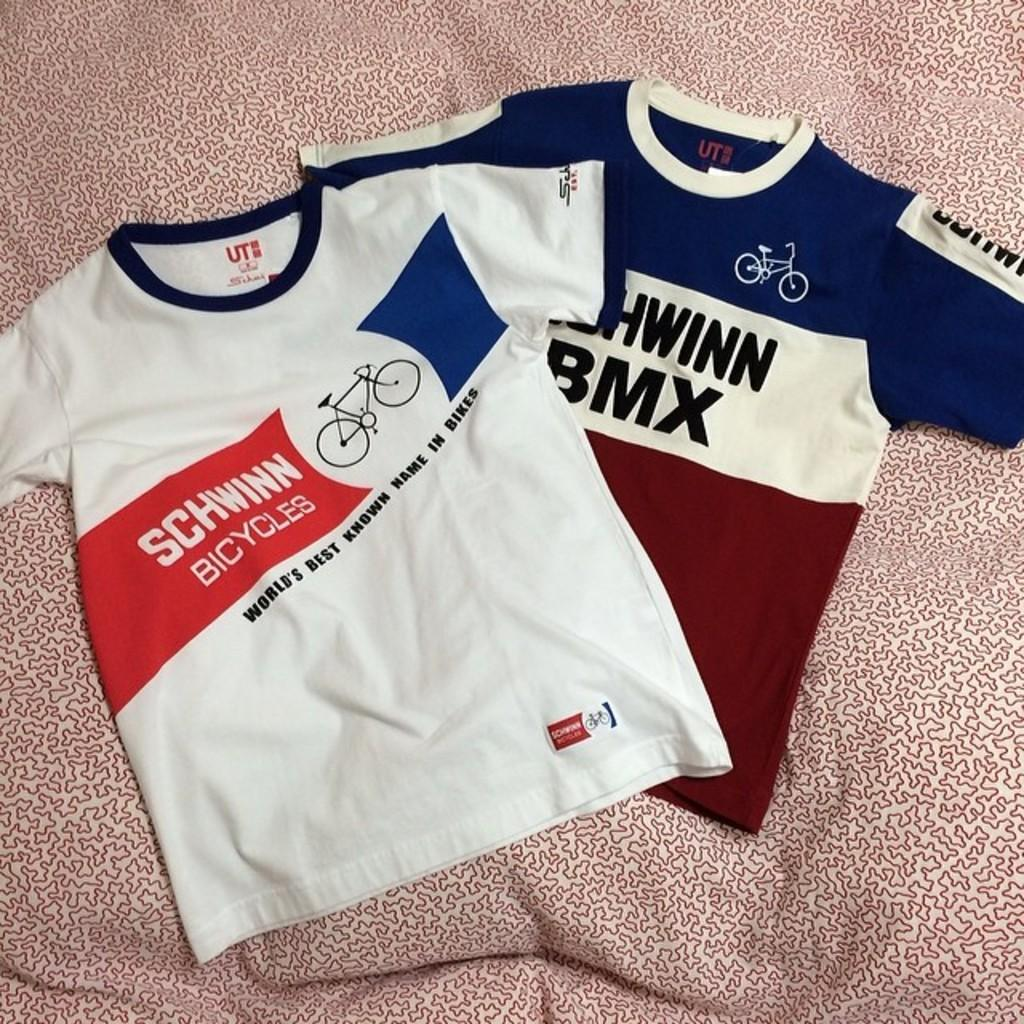<image>
Write a terse but informative summary of the picture. A Schwinn Bicycles shirt is lying on a bed next to another shirt. 